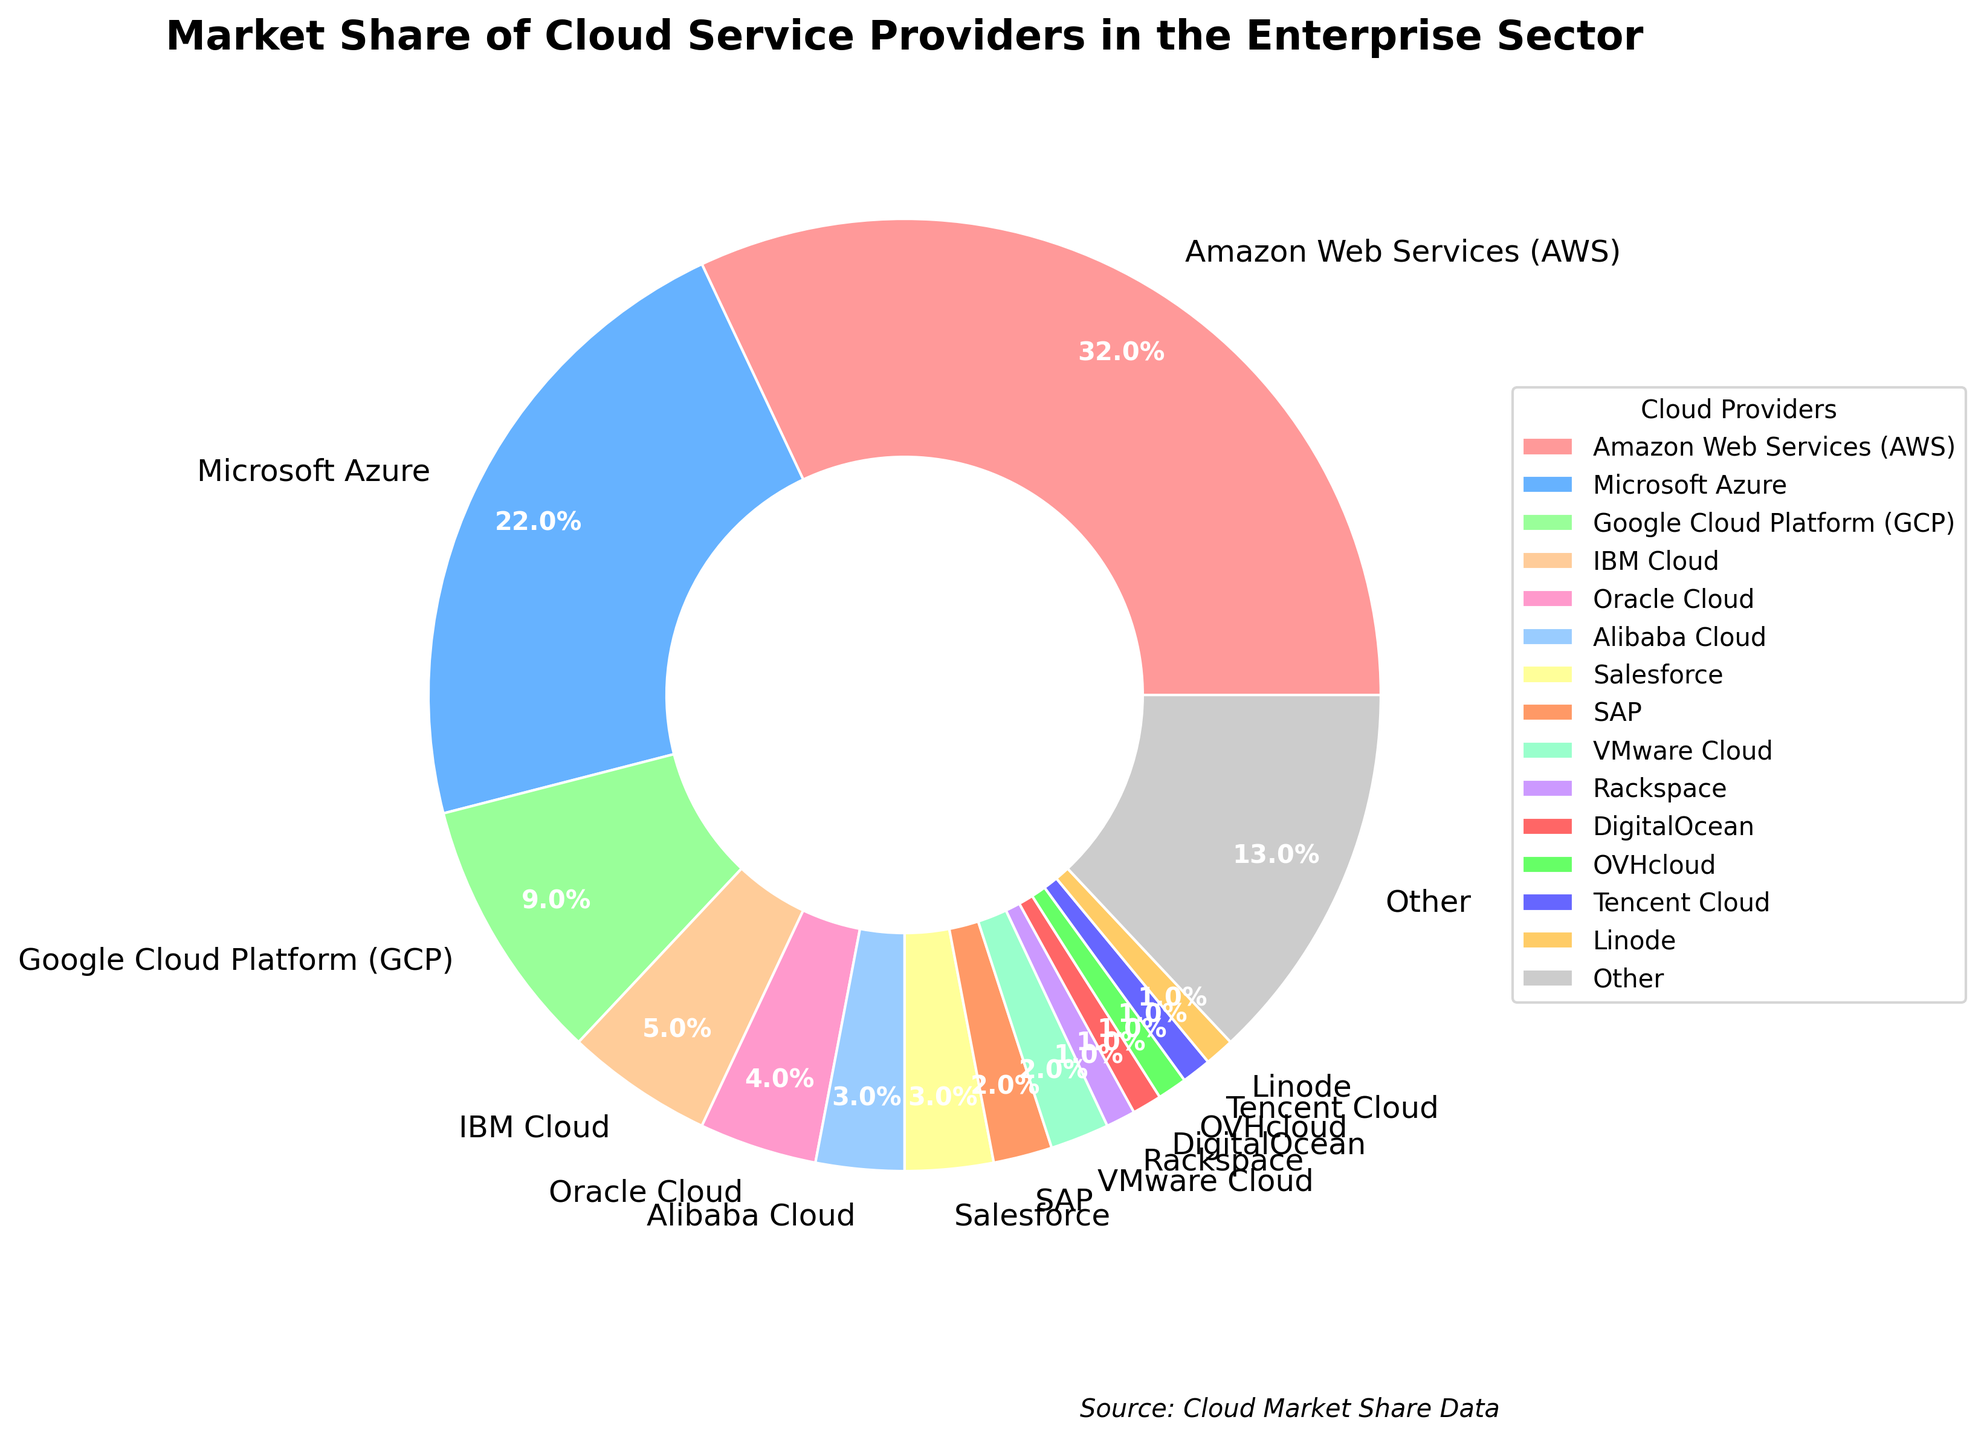What is the market share of Amazon Web Services (AWS)? The pie chart shows the market share directly for each provider. AWS occupies the largest segment.
Answer: 32% Which cloud provider has the second largest market share? By observing the size of segments in the pie chart, Microsoft Azure has the second largest after AWS.
Answer: Microsoft Azure How much greater is the market share of AWS compared to Google Cloud Platform (GCP)? AWS has 32% and GCP has 9%, so the difference is 32% - 9%.
Answer: 23% Which providers have a market share of 1%? There are multiple segments of the same size labeled with 1%. These include Rackspace, DigitalOcean, OVHcloud, Tencent Cloud, and Linode.
Answer: Rackspace, DigitalOcean, OVHcloud, Tencent Cloud, Linode What is the combined market share of Oracle Cloud and IBM Cloud? Add the market share percentages of Oracle Cloud (4%) and IBM Cloud (5%).
Answer: 9% How does the market share of Microsoft Azure compare to Alibaba Cloud? Microsoft Azure has a market share of 22%, while Alibaba Cloud has 3%. Therefore, Microsoft Azure's market share is significantly higher.
Answer: Microsoft Azure is greater Which cloud provider has the smallest market share, and what is its value? Several cloud providers have the smallest equal market share of 1%, and they are Rackspace, DigitalOcean, OVHcloud, Tencent Cloud, and Linode.
Answer: 1% What is the total market share of the top three cloud providers? The top three cloud providers are AWS (32%), Microsoft Azure (22%), and GCP (9%). Add these percentages together: 32% + 22% + 9%.
Answer: 63% How much larger is the market share of AWS compared to the combined market share of Salesforce and SAP? AWS has 32%, and the combined market share of Salesforce (3%) and SAP (2%) is 5%. Subtract: 32% - 5%.
Answer: 27% What color is used to represent Oracle Cloud in the chart? Identify the segment labeled as Oracle Cloud and note its color. In this chart, it is colored in a specific shade.
Answer: It's the color that represents Oracle Cloud in the chart, frequently a unique shade or assigned color 